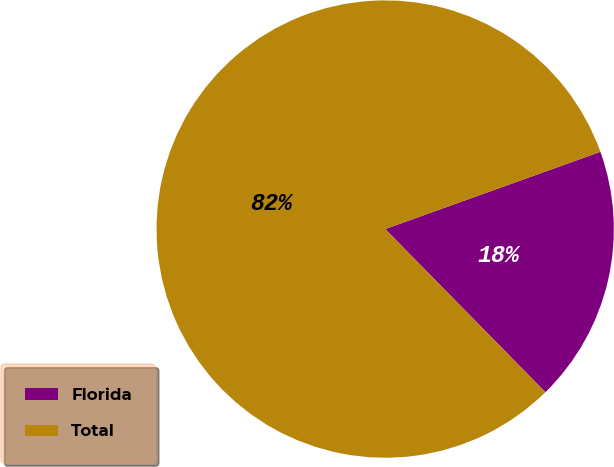Convert chart to OTSL. <chart><loc_0><loc_0><loc_500><loc_500><pie_chart><fcel>Florida<fcel>Total<nl><fcel>18.13%<fcel>81.87%<nl></chart> 